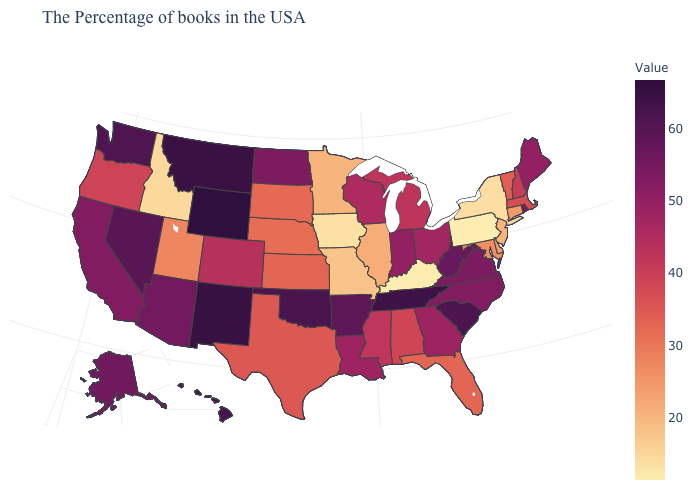Among the states that border South Carolina , which have the highest value?
Keep it brief. North Carolina. Among the states that border Missouri , which have the highest value?
Write a very short answer. Tennessee. Which states hav the highest value in the West?
Keep it brief. Wyoming. Does Idaho have the lowest value in the West?
Give a very brief answer. Yes. Does Wyoming have the highest value in the West?
Answer briefly. Yes. Does Maine have a higher value than Oregon?
Keep it brief. Yes. Does Kentucky have the lowest value in the South?
Concise answer only. Yes. Among the states that border Connecticut , which have the lowest value?
Short answer required. New York. 